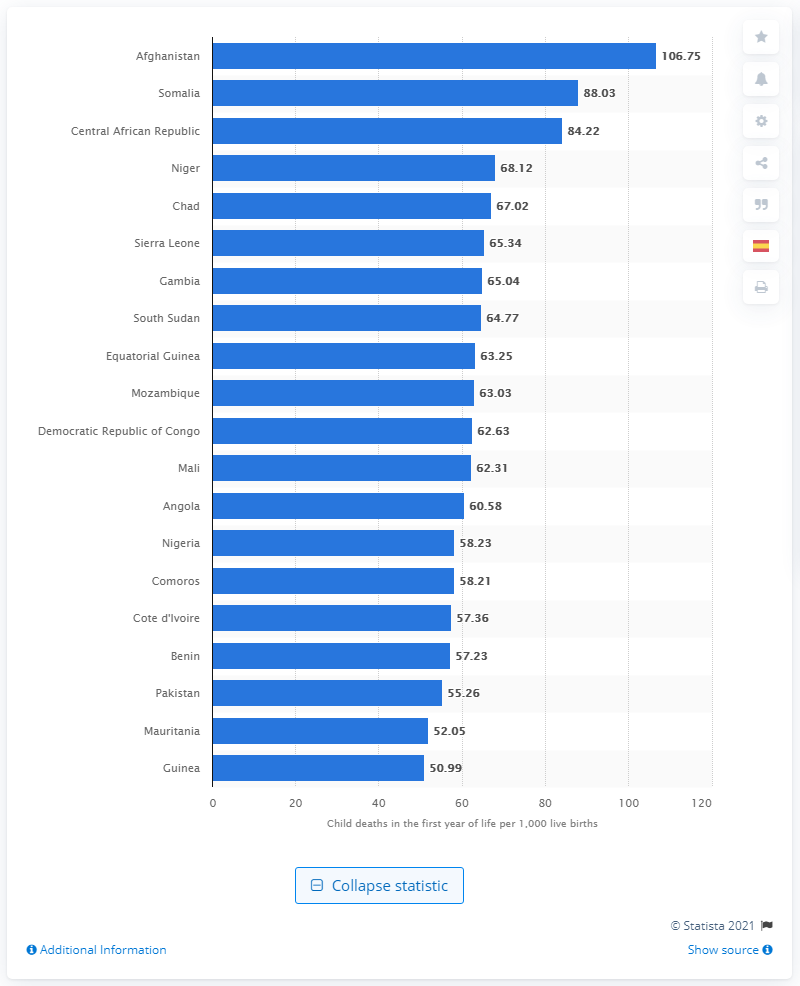Point out several critical features in this image. In 2021, it is estimated that 106.75 infants out of every 1,000 live births in Afghanistan died before their first birthday. 